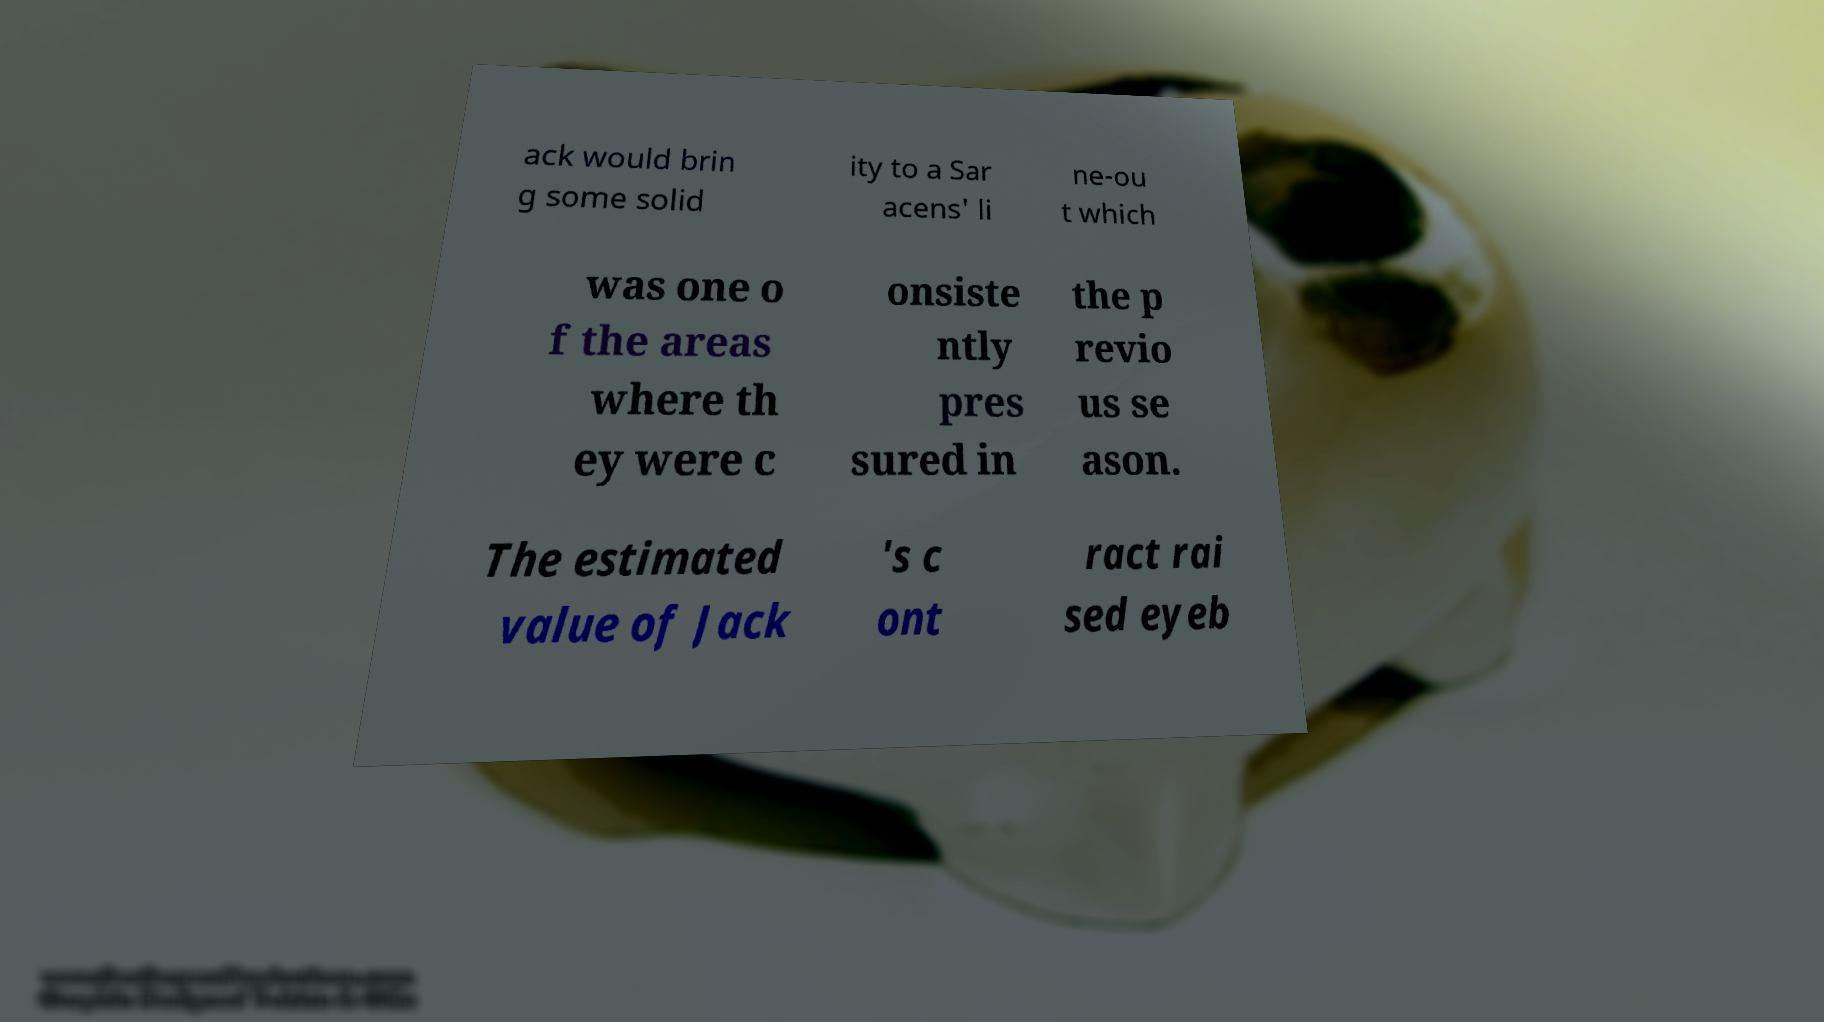Can you accurately transcribe the text from the provided image for me? ack would brin g some solid ity to a Sar acens' li ne-ou t which was one o f the areas where th ey were c onsiste ntly pres sured in the p revio us se ason. The estimated value of Jack 's c ont ract rai sed eyeb 